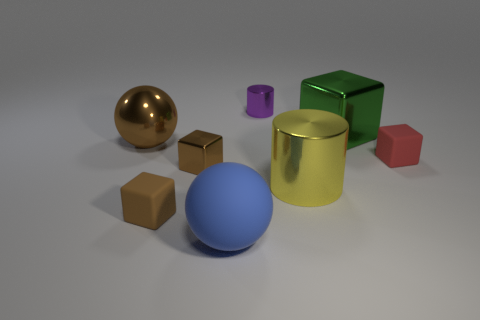Subtract all small shiny cubes. How many cubes are left? 3 Subtract 1 cubes. How many cubes are left? 3 Subtract all red cubes. How many cubes are left? 3 Add 1 blue spheres. How many objects exist? 9 Subtract all yellow cubes. Subtract all purple spheres. How many cubes are left? 4 Subtract all cylinders. How many objects are left? 6 Add 5 shiny spheres. How many shiny spheres are left? 6 Add 1 big blocks. How many big blocks exist? 2 Subtract 1 purple cylinders. How many objects are left? 7 Subtract all tiny yellow balls. Subtract all purple metallic things. How many objects are left? 7 